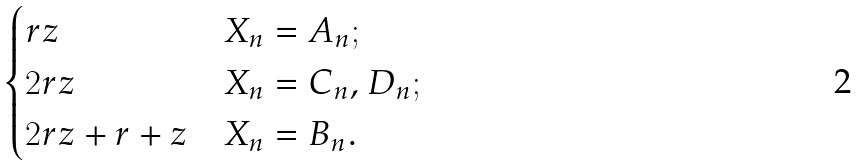Convert formula to latex. <formula><loc_0><loc_0><loc_500><loc_500>\begin{cases} r z & \text {$X_{n}=A_{n}$} ; \\ 2 r z & \text {$X_{n}=C_{n}$, $D_{n}$} ; \\ 2 r z + r + z & \text {$X_{n}=B_{n}$} . \end{cases}</formula> 